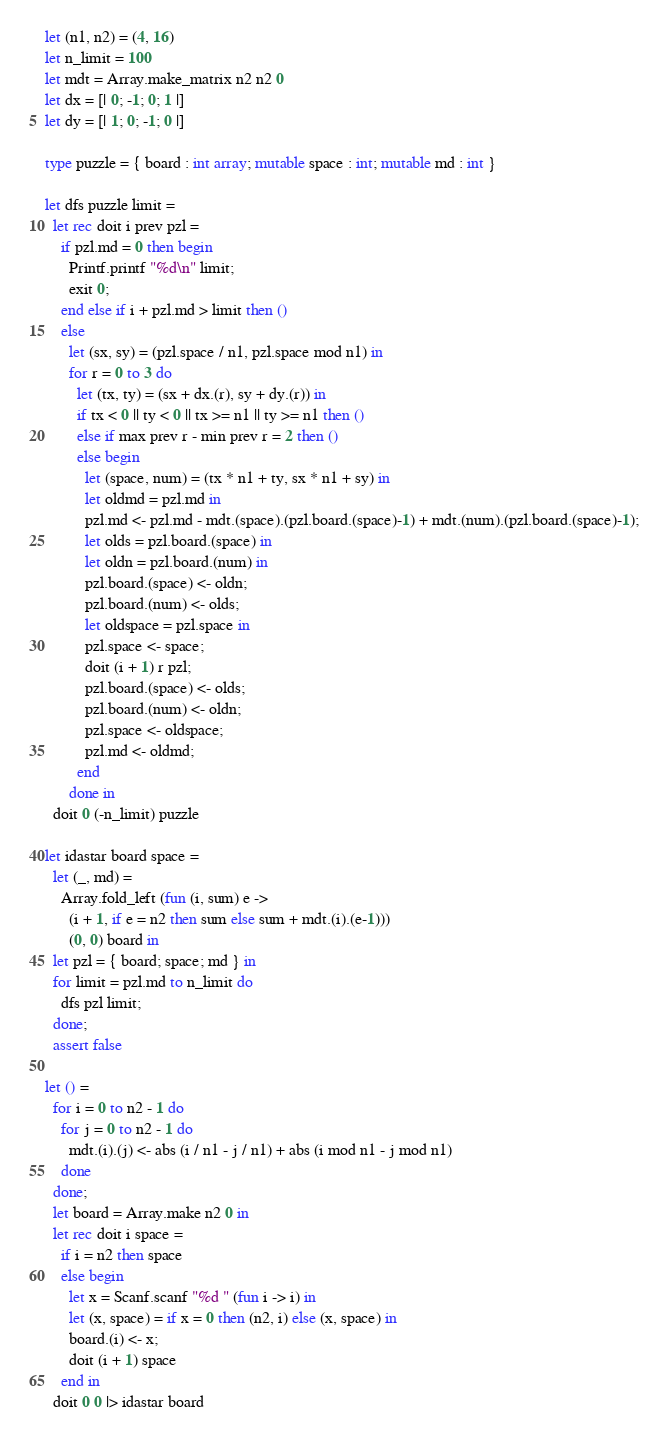<code> <loc_0><loc_0><loc_500><loc_500><_OCaml_>let (n1, n2) = (4, 16)
let n_limit = 100
let mdt = Array.make_matrix n2 n2 0
let dx = [| 0; -1; 0; 1 |]
let dy = [| 1; 0; -1; 0 |]

type puzzle = { board : int array; mutable space : int; mutable md : int }

let dfs puzzle limit =
  let rec doit i prev pzl =
    if pzl.md = 0 then begin
      Printf.printf "%d\n" limit;
      exit 0;
    end else if i + pzl.md > limit then ()
    else
      let (sx, sy) = (pzl.space / n1, pzl.space mod n1) in
      for r = 0 to 3 do
        let (tx, ty) = (sx + dx.(r), sy + dy.(r)) in
        if tx < 0 || ty < 0 || tx >= n1 || ty >= n1 then ()
        else if max prev r - min prev r = 2 then ()
        else begin
          let (space, num) = (tx * n1 + ty, sx * n1 + sy) in
          let oldmd = pzl.md in
          pzl.md <- pzl.md - mdt.(space).(pzl.board.(space)-1) + mdt.(num).(pzl.board.(space)-1);
          let olds = pzl.board.(space) in
          let oldn = pzl.board.(num) in
          pzl.board.(space) <- oldn;
          pzl.board.(num) <- olds;
          let oldspace = pzl.space in
          pzl.space <- space;
          doit (i + 1) r pzl;
          pzl.board.(space) <- olds;
          pzl.board.(num) <- oldn;
          pzl.space <- oldspace;
          pzl.md <- oldmd;
        end
      done in
  doit 0 (-n_limit) puzzle

let idastar board space =
  let (_, md) =
    Array.fold_left (fun (i, sum) e ->
      (i + 1, if e = n2 then sum else sum + mdt.(i).(e-1)))
      (0, 0) board in
  let pzl = { board; space; md } in
  for limit = pzl.md to n_limit do
    dfs pzl limit;
  done;
  assert false

let () =
  for i = 0 to n2 - 1 do
    for j = 0 to n2 - 1 do
      mdt.(i).(j) <- abs (i / n1 - j / n1) + abs (i mod n1 - j mod n1)
    done
  done;
  let board = Array.make n2 0 in
  let rec doit i space =
    if i = n2 then space
    else begin
      let x = Scanf.scanf "%d " (fun i -> i) in
      let (x, space) = if x = 0 then (n2, i) else (x, space) in
      board.(i) <- x;
      doit (i + 1) space
    end in
  doit 0 0 |> idastar board</code> 